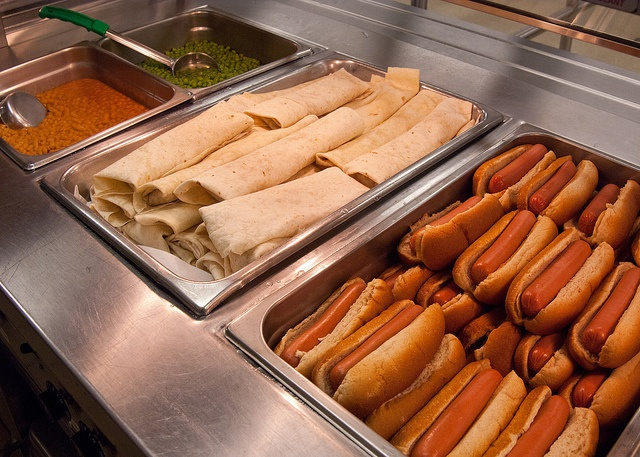Describe the objects in this image and their specific colors. I can see hot dog in maroon, brown, and tan tones, hot dog in maroon, brown, and red tones, hot dog in maroon, brown, red, and tan tones, hot dog in maroon, red, and brown tones, and hot dog in maroon, red, and brown tones in this image. 